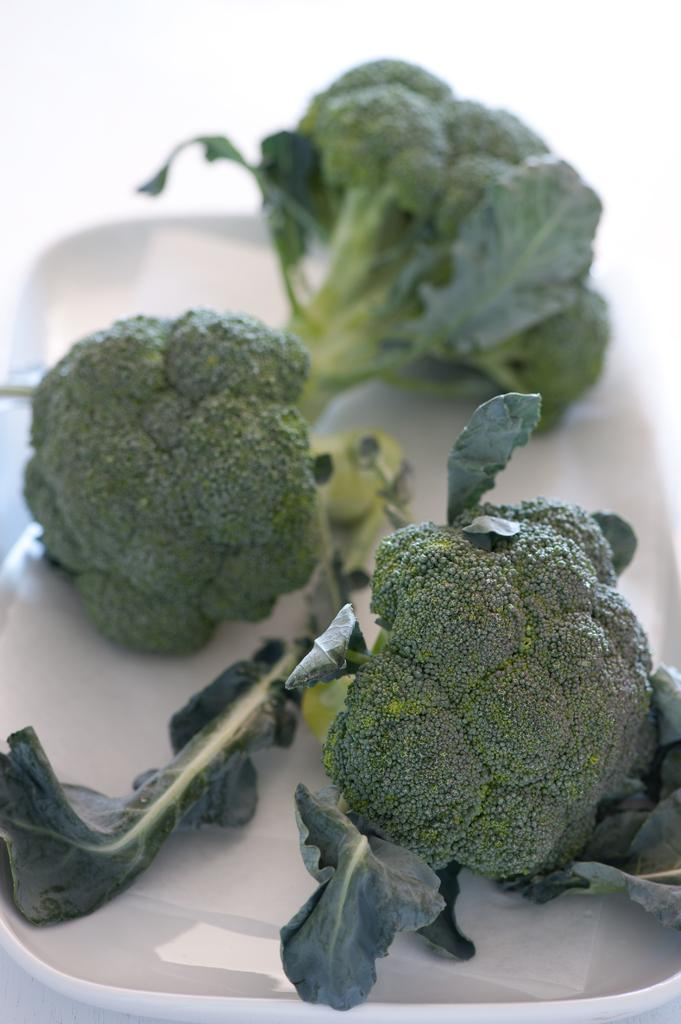What is the color of the surface in the image? The surface in the image is white colored. What is placed on the surface? There is a white colored plate on the surface. What is on the plate? There are broccoli pieces on the plate. What is the color of the broccoli pieces? The broccoli pieces are green in color. What grade of scissors is being used to cut the broccoli in the image? There are no scissors or cutting activity visible in the image. What type of wash is being used to clean the broccoli in the image? There is no washing activity or mention of a specific wash in the image. 